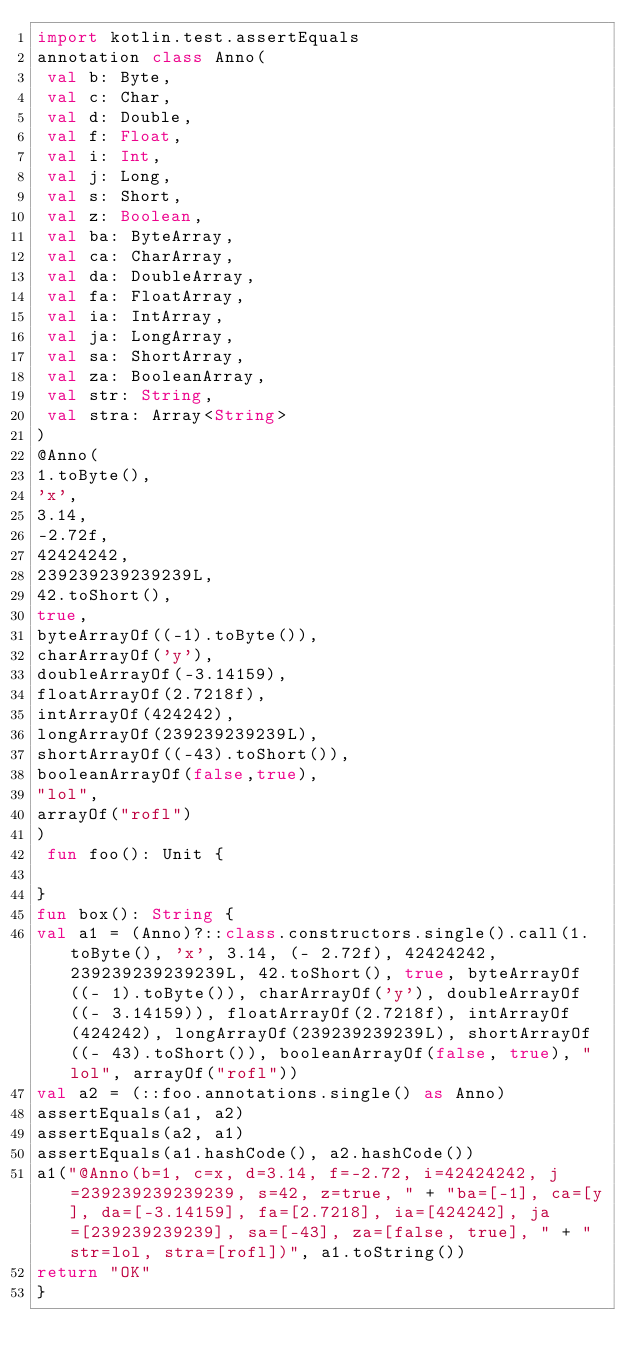<code> <loc_0><loc_0><loc_500><loc_500><_Kotlin_>import kotlin.test.assertEquals
annotation class Anno(
 val b: Byte,
 val c: Char,
 val d: Double,
 val f: Float,
 val i: Int,
 val j: Long,
 val s: Short,
 val z: Boolean,
 val ba: ByteArray,
 val ca: CharArray,
 val da: DoubleArray,
 val fa: FloatArray,
 val ia: IntArray,
 val ja: LongArray,
 val sa: ShortArray,
 val za: BooleanArray,
 val str: String,
 val stra: Array<String>
)
@Anno(
1.toByte(),
'x',
3.14,
-2.72f,
42424242,
239239239239239L,
42.toShort(),
true,
byteArrayOf((-1).toByte()),
charArrayOf('y'),
doubleArrayOf(-3.14159),
floatArrayOf(2.7218f),
intArrayOf(424242),
longArrayOf(239239239239L),
shortArrayOf((-43).toShort()),
booleanArrayOf(false,true),
"lol",
arrayOf("rofl")
)
 fun foo(): Unit {

}
fun box(): String {
val a1 = (Anno)?::class.constructors.single().call(1.toByte(), 'x', 3.14, (- 2.72f), 42424242, 239239239239239L, 42.toShort(), true, byteArrayOf((- 1).toByte()), charArrayOf('y'), doubleArrayOf((- 3.14159)), floatArrayOf(2.7218f), intArrayOf(424242), longArrayOf(239239239239L), shortArrayOf((- 43).toShort()), booleanArrayOf(false, true), "lol", arrayOf("rofl"))
val a2 = (::foo.annotations.single() as Anno)
assertEquals(a1, a2)
assertEquals(a2, a1)
assertEquals(a1.hashCode(), a2.hashCode())
a1("@Anno(b=1, c=x, d=3.14, f=-2.72, i=42424242, j=239239239239239, s=42, z=true, " + "ba=[-1], ca=[y], da=[-3.14159], fa=[2.7218], ia=[424242], ja=[239239239239], sa=[-43], za=[false, true], " + "str=lol, stra=[rofl])", a1.toString())
return "OK"
}</code> 